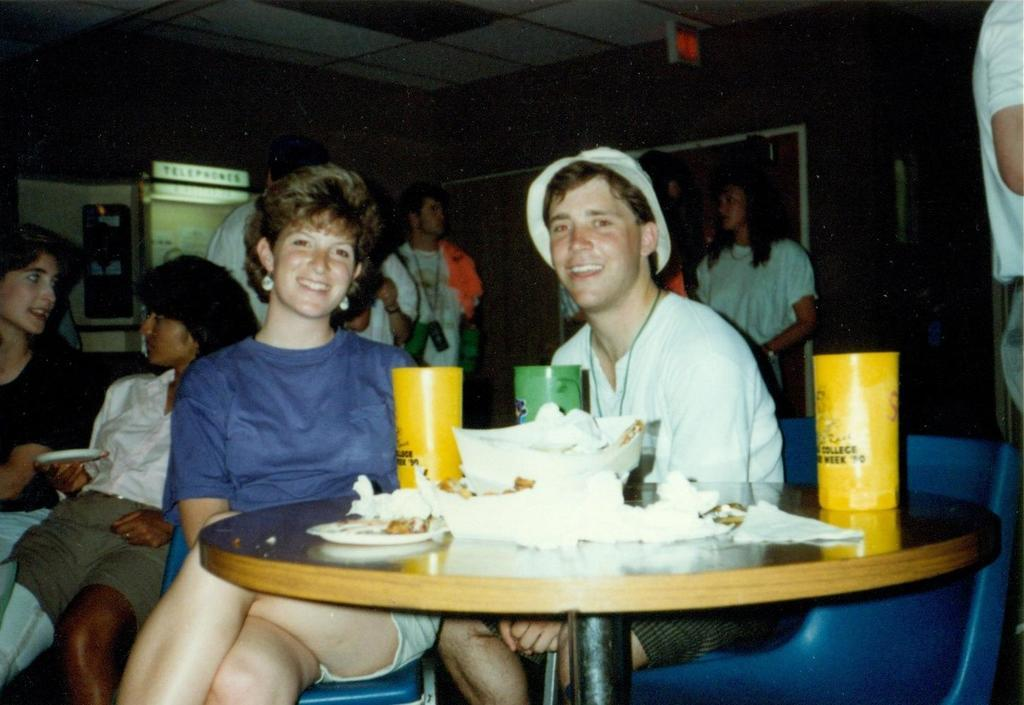What is happening in the room in the image? There are people sitting in a room, and some people are standing behind them. What is on the table in front of the sitting people? There are glasses and tissues on the table. Where are the standing people positioned in relation to the sitting people? The standing people are behind the sitting people. What is behind the standing people? The standing people are in front of a wall. What type of lace is being exchanged between the people in the image? There is no lace or exchange of any items visible in the image. Can you tell me how many monkeys are sitting at the table in the image? There are no monkeys present in the image; it features people sitting and standing. 